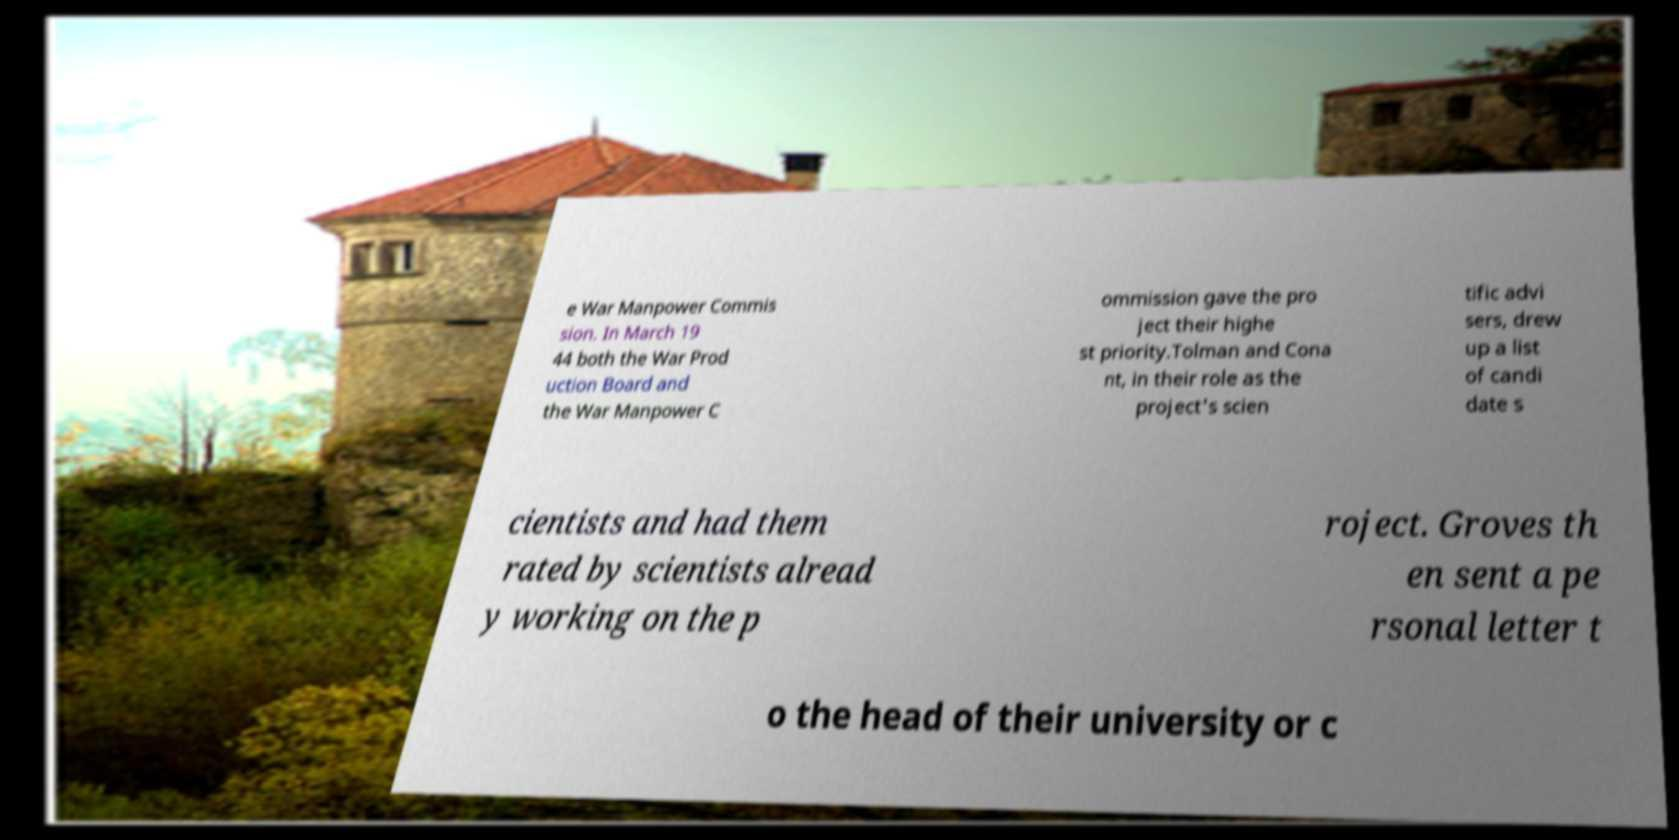For documentation purposes, I need the text within this image transcribed. Could you provide that? e War Manpower Commis sion. In March 19 44 both the War Prod uction Board and the War Manpower C ommission gave the pro ject their highe st priority.Tolman and Cona nt, in their role as the project's scien tific advi sers, drew up a list of candi date s cientists and had them rated by scientists alread y working on the p roject. Groves th en sent a pe rsonal letter t o the head of their university or c 